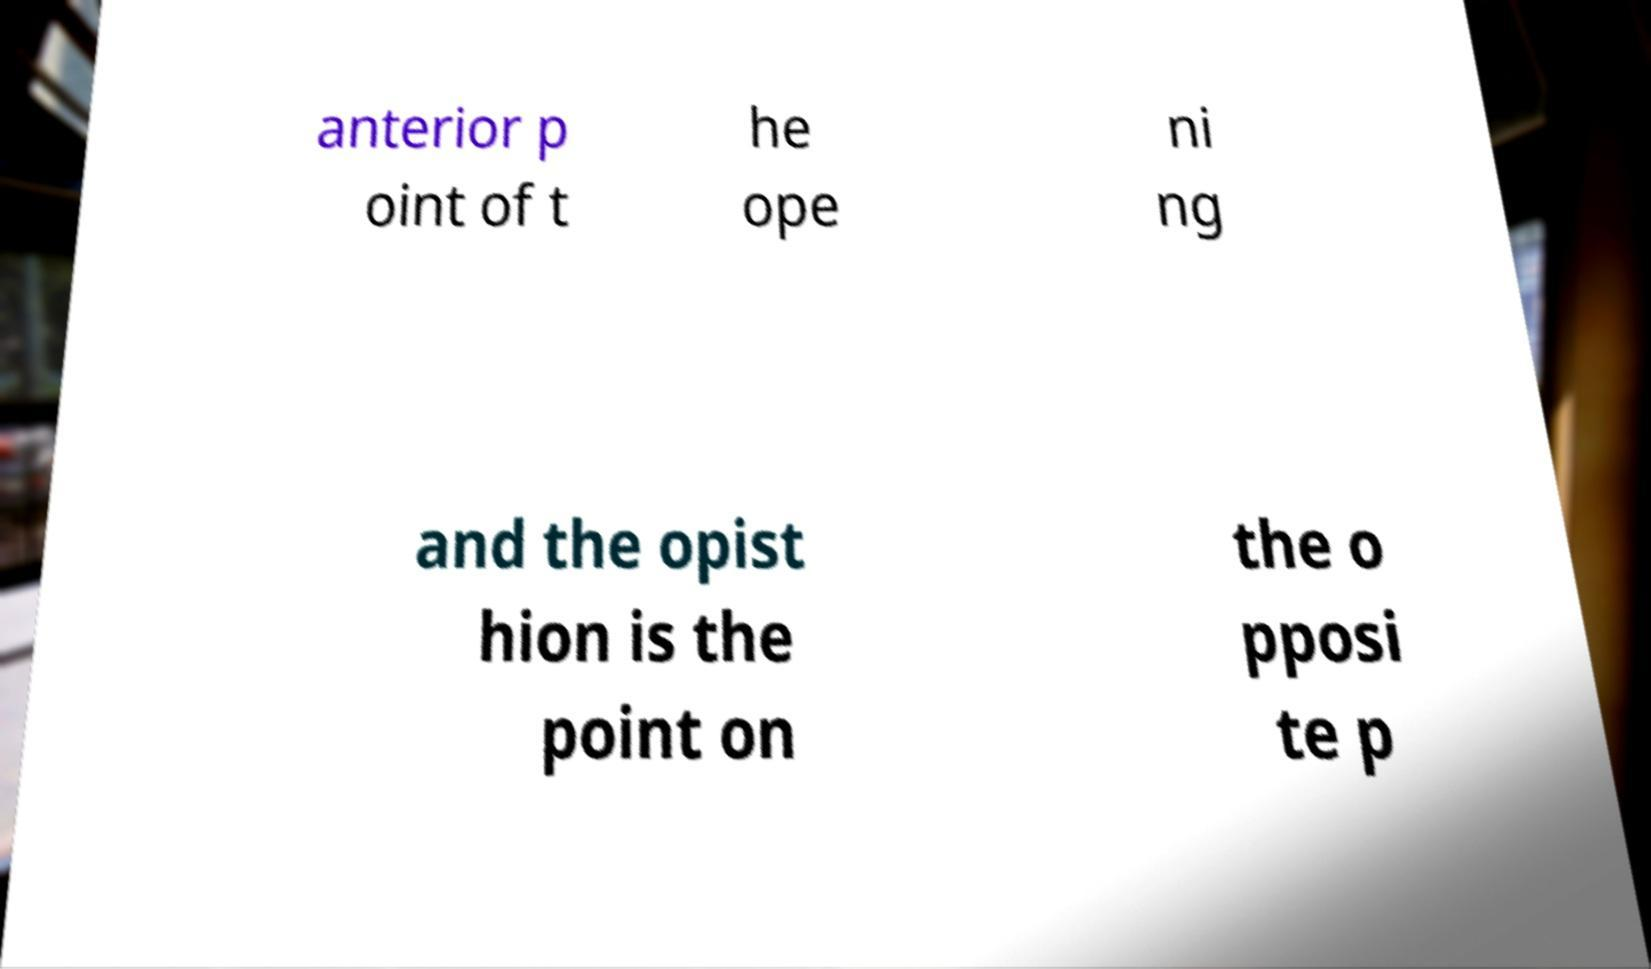There's text embedded in this image that I need extracted. Can you transcribe it verbatim? anterior p oint of t he ope ni ng and the opist hion is the point on the o pposi te p 